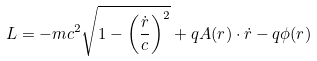Convert formula to latex. <formula><loc_0><loc_0><loc_500><loc_500>L = - m c ^ { 2 } { \sqrt { 1 - \left ( { \frac { \dot { r } } { c } } \right ) ^ { 2 } } } + q A ( r ) \cdot { \dot { r } } - q \phi ( r ) \,</formula> 